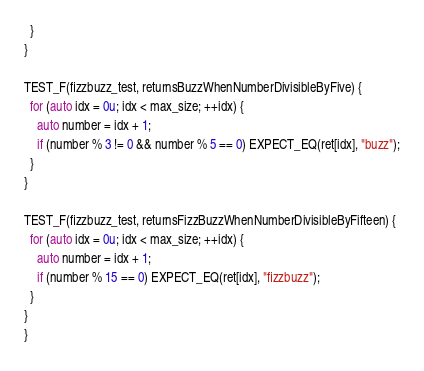<code> <loc_0><loc_0><loc_500><loc_500><_C++_>  }
}

TEST_F(fizzbuzz_test, returnsBuzzWhenNumberDivisibleByFive) {
  for (auto idx = 0u; idx < max_size; ++idx) {
    auto number = idx + 1;
    if (number % 3 != 0 && number % 5 == 0) EXPECT_EQ(ret[idx], "buzz");
  }
}

TEST_F(fizzbuzz_test, returnsFizzBuzzWhenNumberDivisibleByFifteen) {
  for (auto idx = 0u; idx < max_size; ++idx) {
    auto number = idx + 1;
    if (number % 15 == 0) EXPECT_EQ(ret[idx], "fizzbuzz");
  }
}
}
</code> 